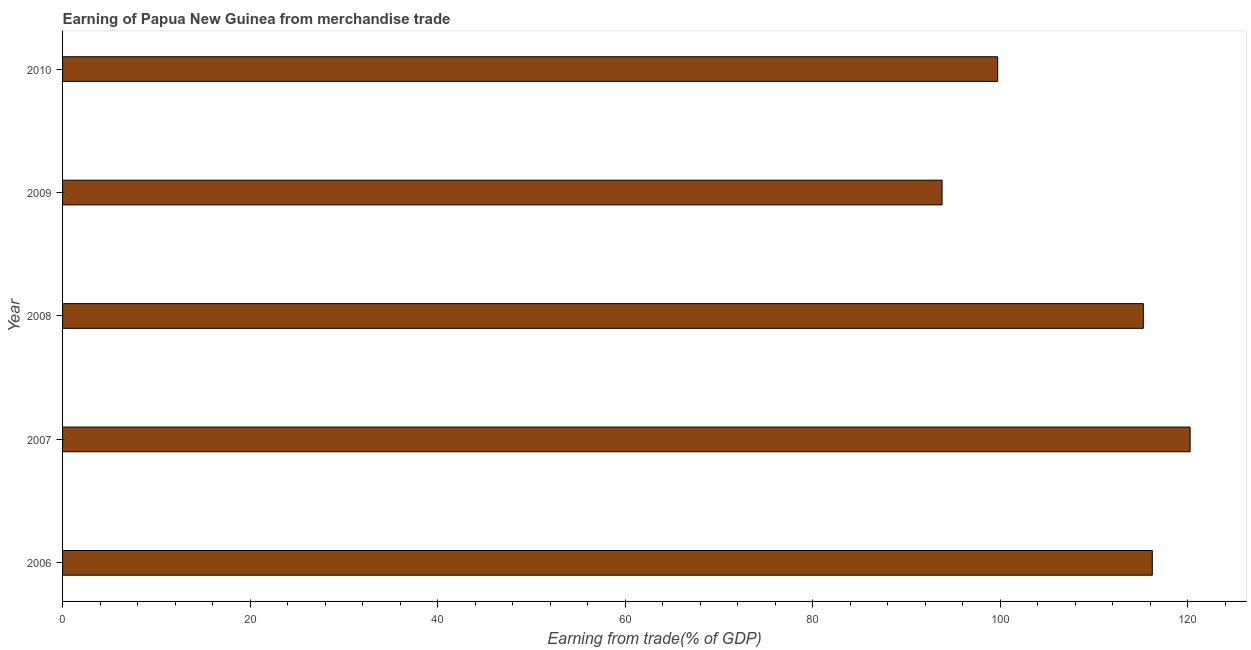Does the graph contain grids?
Keep it short and to the point. No. What is the title of the graph?
Offer a terse response. Earning of Papua New Guinea from merchandise trade. What is the label or title of the X-axis?
Offer a very short reply. Earning from trade(% of GDP). What is the earning from merchandise trade in 2009?
Your answer should be very brief. 93.82. Across all years, what is the maximum earning from merchandise trade?
Offer a very short reply. 120.28. Across all years, what is the minimum earning from merchandise trade?
Ensure brevity in your answer.  93.82. In which year was the earning from merchandise trade maximum?
Offer a terse response. 2007. What is the sum of the earning from merchandise trade?
Offer a very short reply. 545.38. What is the difference between the earning from merchandise trade in 2007 and 2008?
Your answer should be very brief. 4.99. What is the average earning from merchandise trade per year?
Keep it short and to the point. 109.08. What is the median earning from merchandise trade?
Offer a very short reply. 115.29. In how many years, is the earning from merchandise trade greater than 52 %?
Your answer should be very brief. 5. Do a majority of the years between 2010 and 2007 (inclusive) have earning from merchandise trade greater than 68 %?
Your answer should be compact. Yes. What is the ratio of the earning from merchandise trade in 2007 to that in 2009?
Offer a terse response. 1.28. What is the difference between the highest and the second highest earning from merchandise trade?
Your answer should be very brief. 4.03. Is the sum of the earning from merchandise trade in 2007 and 2009 greater than the maximum earning from merchandise trade across all years?
Provide a short and direct response. Yes. What is the difference between the highest and the lowest earning from merchandise trade?
Make the answer very short. 26.46. In how many years, is the earning from merchandise trade greater than the average earning from merchandise trade taken over all years?
Ensure brevity in your answer.  3. How many bars are there?
Your answer should be compact. 5. How many years are there in the graph?
Keep it short and to the point. 5. Are the values on the major ticks of X-axis written in scientific E-notation?
Your response must be concise. No. What is the Earning from trade(% of GDP) in 2006?
Make the answer very short. 116.24. What is the Earning from trade(% of GDP) in 2007?
Keep it short and to the point. 120.28. What is the Earning from trade(% of GDP) of 2008?
Make the answer very short. 115.29. What is the Earning from trade(% of GDP) in 2009?
Provide a short and direct response. 93.82. What is the Earning from trade(% of GDP) in 2010?
Ensure brevity in your answer.  99.75. What is the difference between the Earning from trade(% of GDP) in 2006 and 2007?
Offer a very short reply. -4.03. What is the difference between the Earning from trade(% of GDP) in 2006 and 2008?
Make the answer very short. 0.96. What is the difference between the Earning from trade(% of GDP) in 2006 and 2009?
Offer a terse response. 22.43. What is the difference between the Earning from trade(% of GDP) in 2006 and 2010?
Keep it short and to the point. 16.5. What is the difference between the Earning from trade(% of GDP) in 2007 and 2008?
Give a very brief answer. 4.99. What is the difference between the Earning from trade(% of GDP) in 2007 and 2009?
Your answer should be very brief. 26.46. What is the difference between the Earning from trade(% of GDP) in 2007 and 2010?
Keep it short and to the point. 20.53. What is the difference between the Earning from trade(% of GDP) in 2008 and 2009?
Make the answer very short. 21.47. What is the difference between the Earning from trade(% of GDP) in 2008 and 2010?
Provide a succinct answer. 15.54. What is the difference between the Earning from trade(% of GDP) in 2009 and 2010?
Provide a short and direct response. -5.93. What is the ratio of the Earning from trade(% of GDP) in 2006 to that in 2009?
Provide a succinct answer. 1.24. What is the ratio of the Earning from trade(% of GDP) in 2006 to that in 2010?
Your response must be concise. 1.17. What is the ratio of the Earning from trade(% of GDP) in 2007 to that in 2008?
Provide a short and direct response. 1.04. What is the ratio of the Earning from trade(% of GDP) in 2007 to that in 2009?
Ensure brevity in your answer.  1.28. What is the ratio of the Earning from trade(% of GDP) in 2007 to that in 2010?
Give a very brief answer. 1.21. What is the ratio of the Earning from trade(% of GDP) in 2008 to that in 2009?
Offer a very short reply. 1.23. What is the ratio of the Earning from trade(% of GDP) in 2008 to that in 2010?
Keep it short and to the point. 1.16. What is the ratio of the Earning from trade(% of GDP) in 2009 to that in 2010?
Offer a terse response. 0.94. 